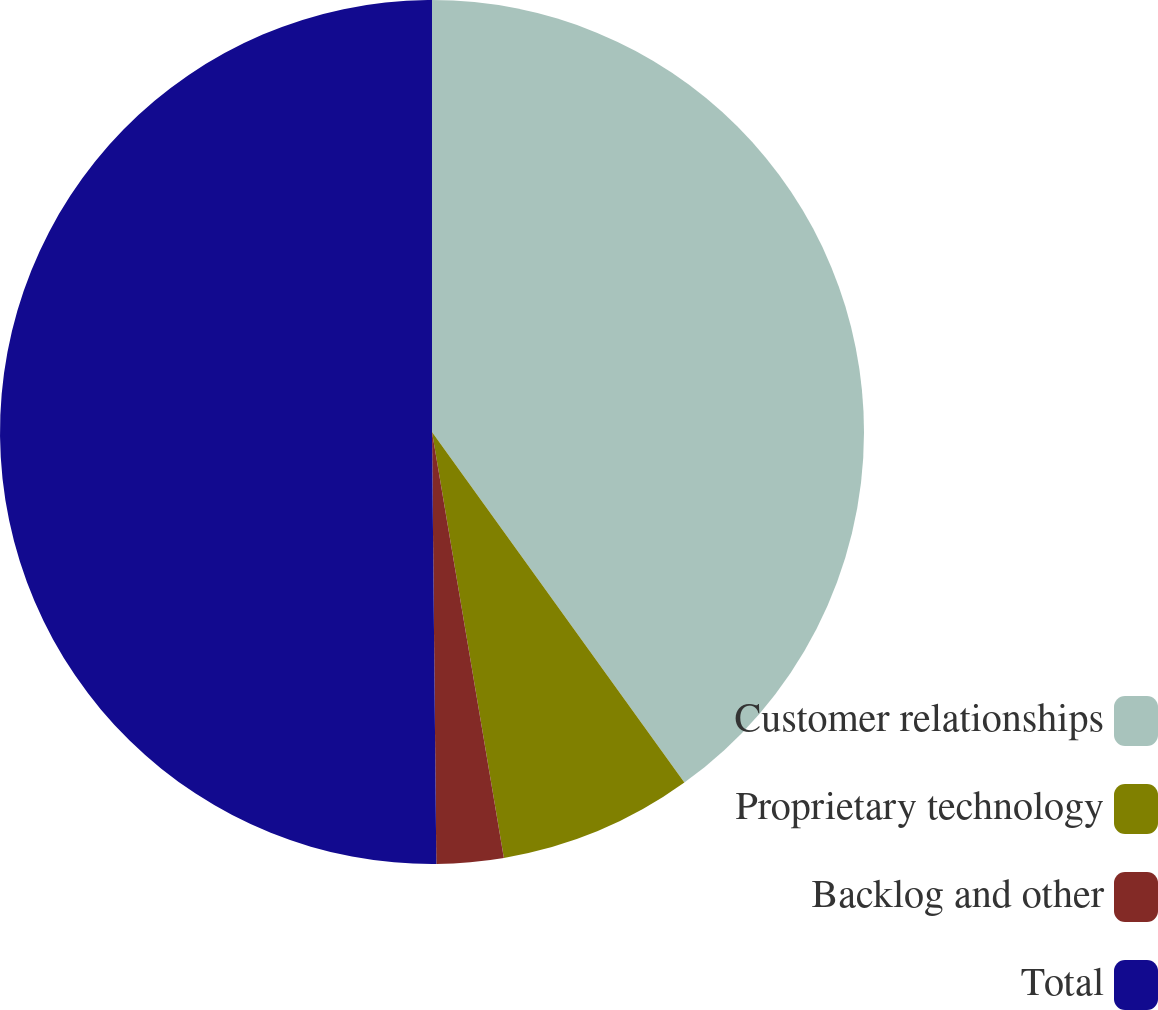Convert chart to OTSL. <chart><loc_0><loc_0><loc_500><loc_500><pie_chart><fcel>Customer relationships<fcel>Proprietary technology<fcel>Backlog and other<fcel>Total<nl><fcel>40.07%<fcel>7.27%<fcel>2.5%<fcel>50.16%<nl></chart> 